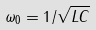Convert formula to latex. <formula><loc_0><loc_0><loc_500><loc_500>\omega _ { 0 } = 1 / \sqrt { L C }</formula> 